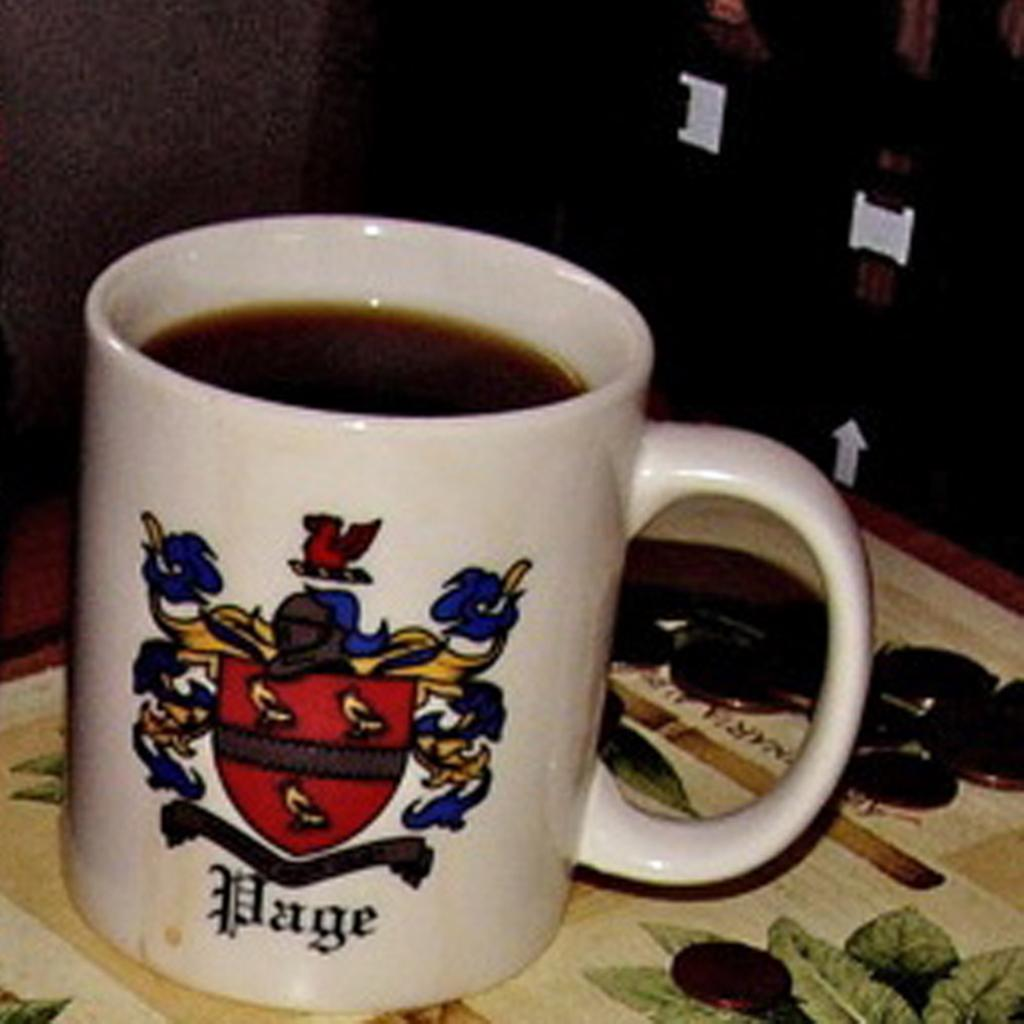<image>
Present a compact description of the photo's key features. A cup of coffee with Page on it. 